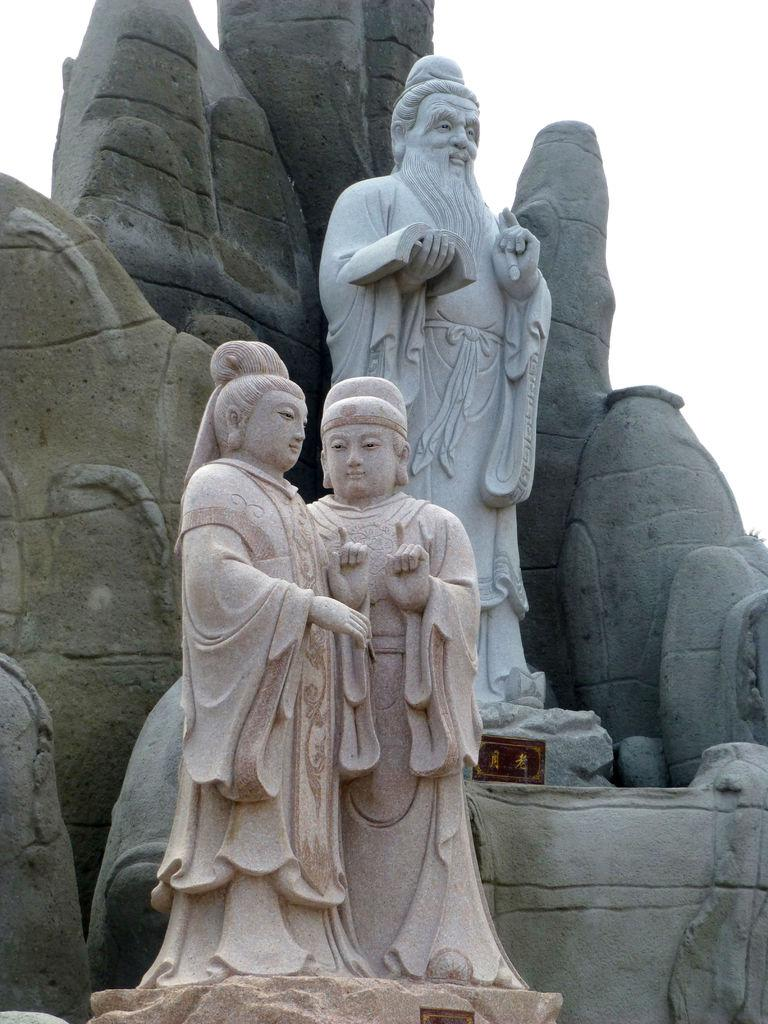What type of objects are present in the image? There are statues in the image. What is the condition of the sky in the image? The sky is cloudy in the image. What type of range can be seen in the image? There is no range present in the image; it features statues and a cloudy sky. Is there a bath visible in the image? There is no bath present in the image. 